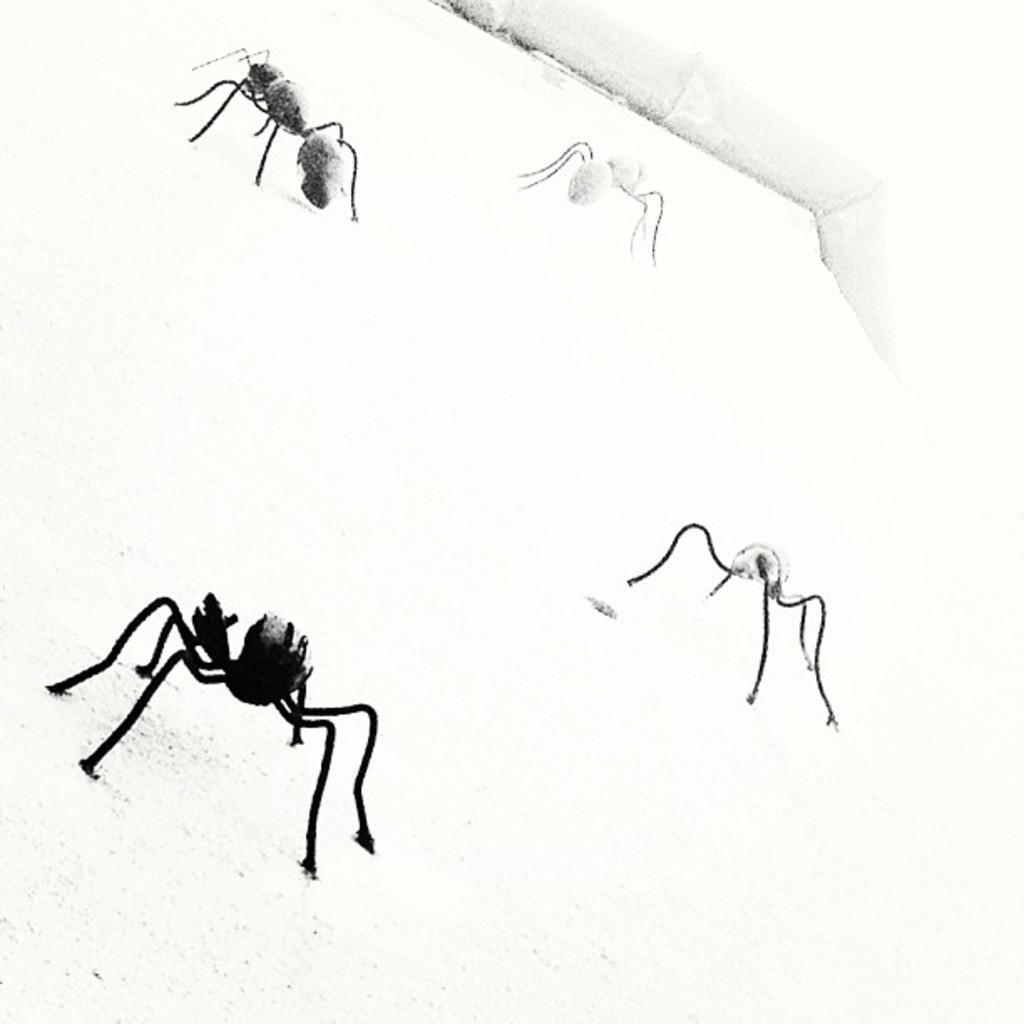Please provide a concise description of this image. In this image, we can see a sketch of some insects on the paper. 